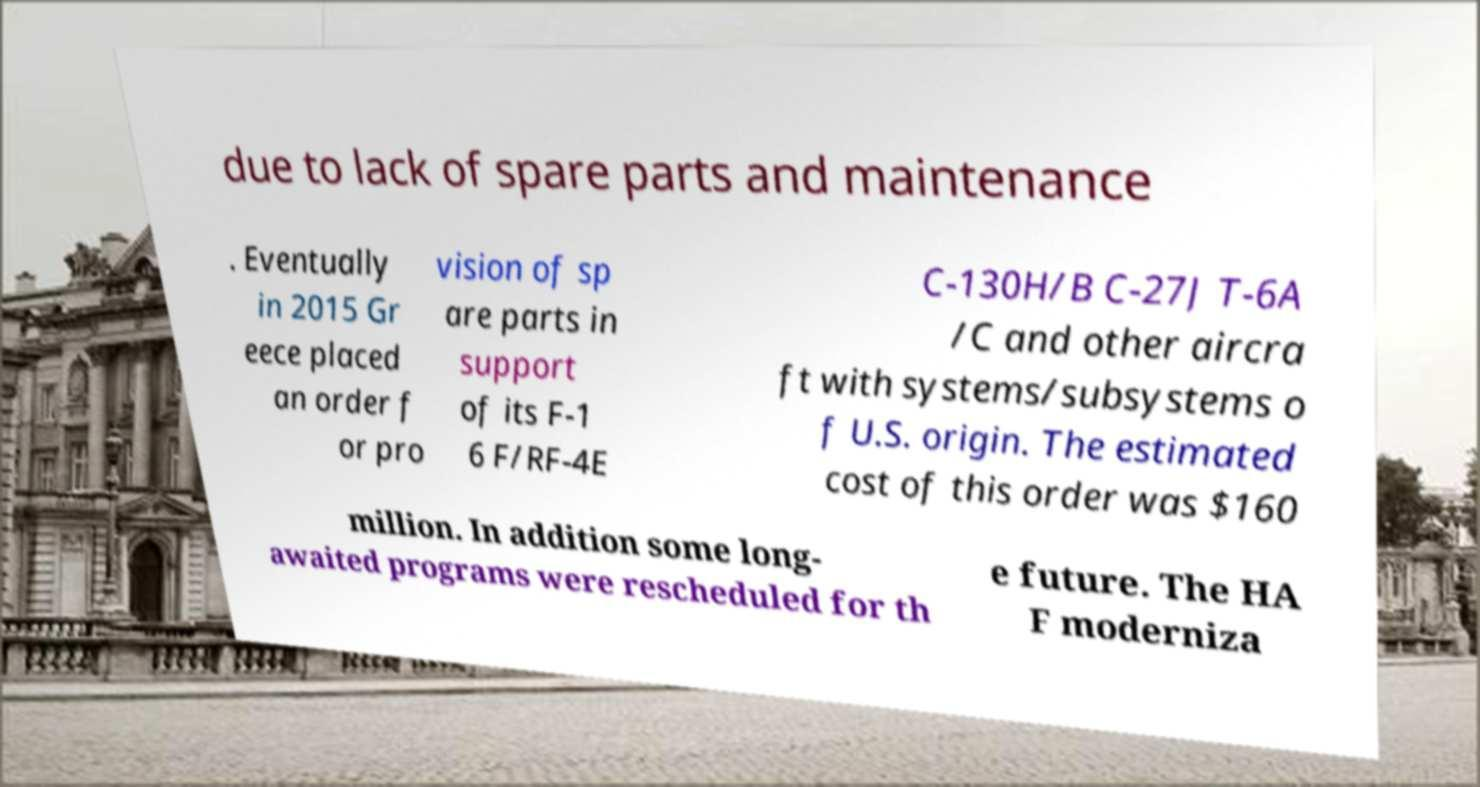I need the written content from this picture converted into text. Can you do that? due to lack of spare parts and maintenance . Eventually in 2015 Gr eece placed an order f or pro vision of sp are parts in support of its F-1 6 F/RF-4E C-130H/B C-27J T-6A /C and other aircra ft with systems/subsystems o f U.S. origin. The estimated cost of this order was $160 million. In addition some long- awaited programs were rescheduled for th e future. The HA F moderniza 